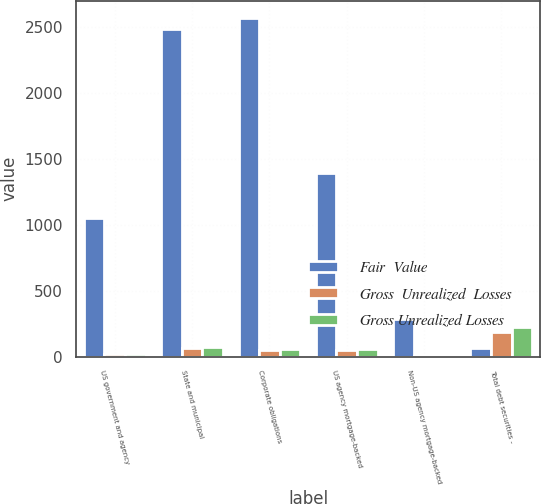Convert chart to OTSL. <chart><loc_0><loc_0><loc_500><loc_500><stacked_bar_chart><ecel><fcel>US government and agency<fcel>State and municipal<fcel>Corporate obligations<fcel>US agency mortgage-backed<fcel>Non-US agency mortgage-backed<fcel>Total debt securities -<nl><fcel>Fair  Value<fcel>1055<fcel>2491<fcel>2573<fcel>1393<fcel>289<fcel>62<nl><fcel>Gross  Unrealized  Losses<fcel>19<fcel>62<fcel>51<fcel>51<fcel>6<fcel>189<nl><fcel>Gross Unrealized Losses<fcel>21<fcel>72<fcel>60<fcel>61<fcel>7<fcel>221<nl></chart> 